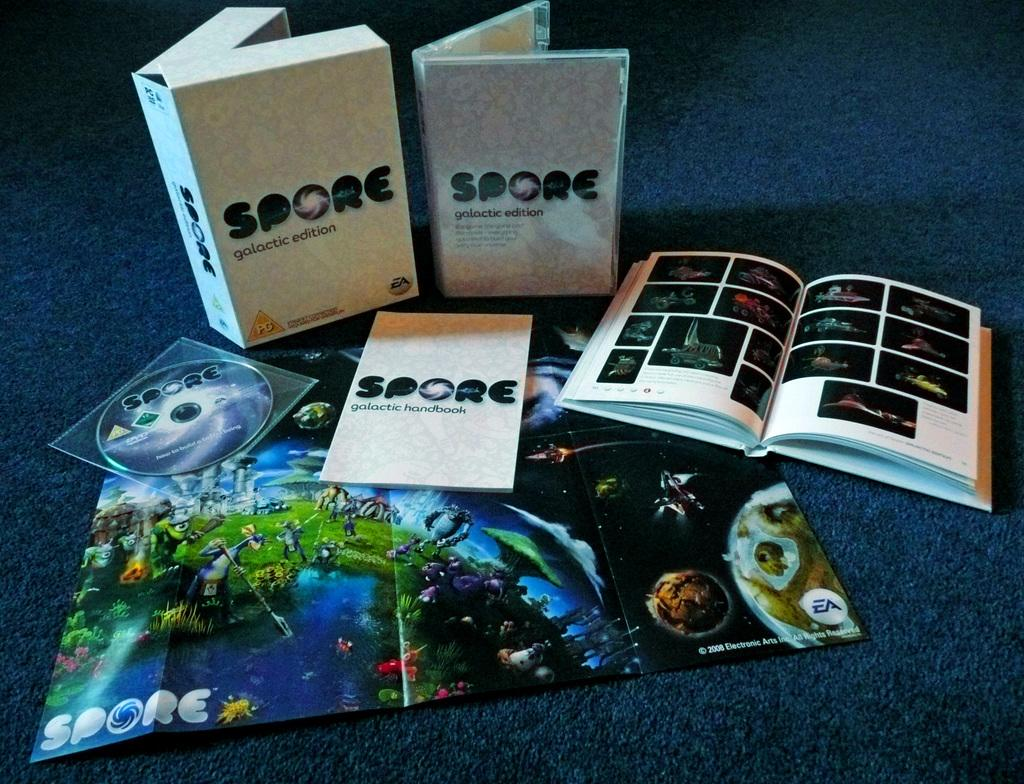<image>
Create a compact narrative representing the image presented. The Spore Galactic Edition includes a DVD, a handbook, a book and a poster. 